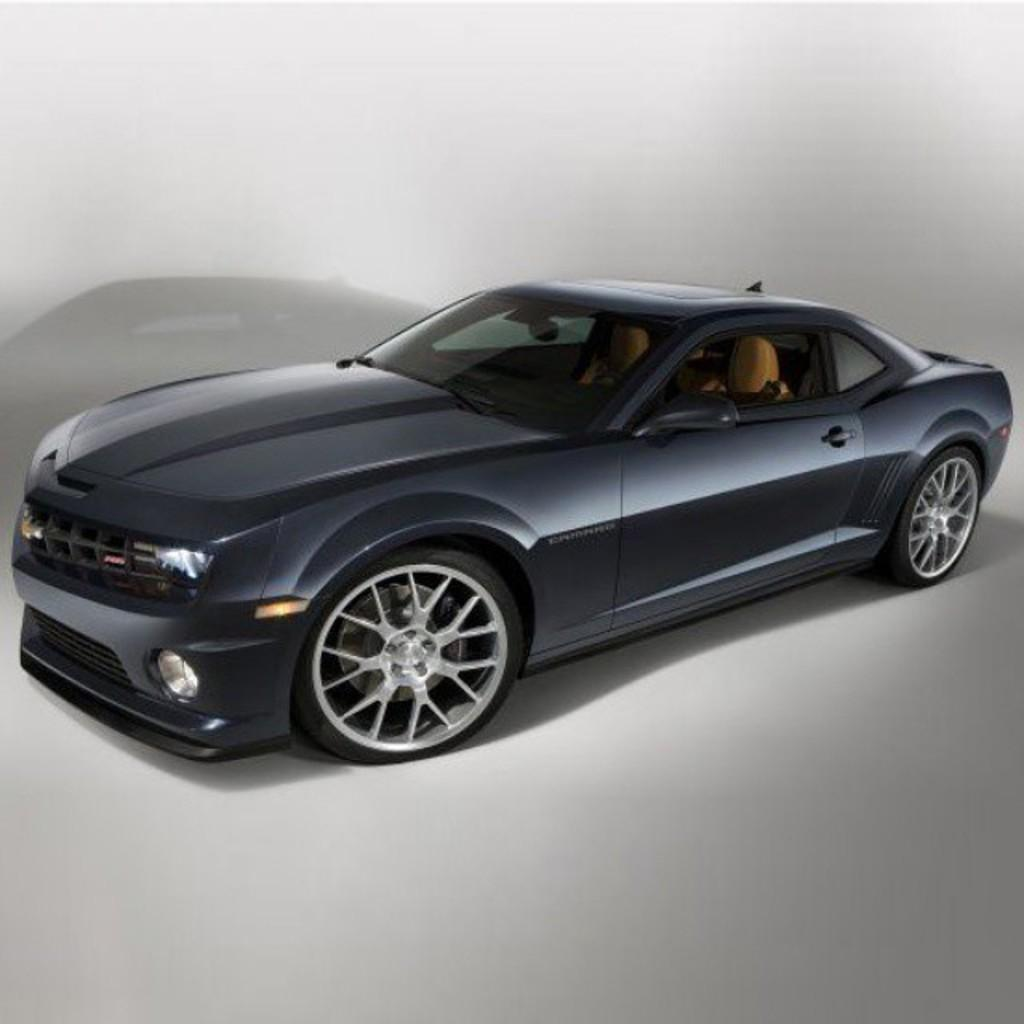What type of vehicle is in the image? There is a black color car in the image. Where is the car located in the image? The car is in the center of the image. What color is the background of the image? The background of the image is white. Can you see a cap on the car in the image? There is no cap visible on the car in the image. Is there a cabbage growing next to the car in the image? There is no cabbage present in the image. 